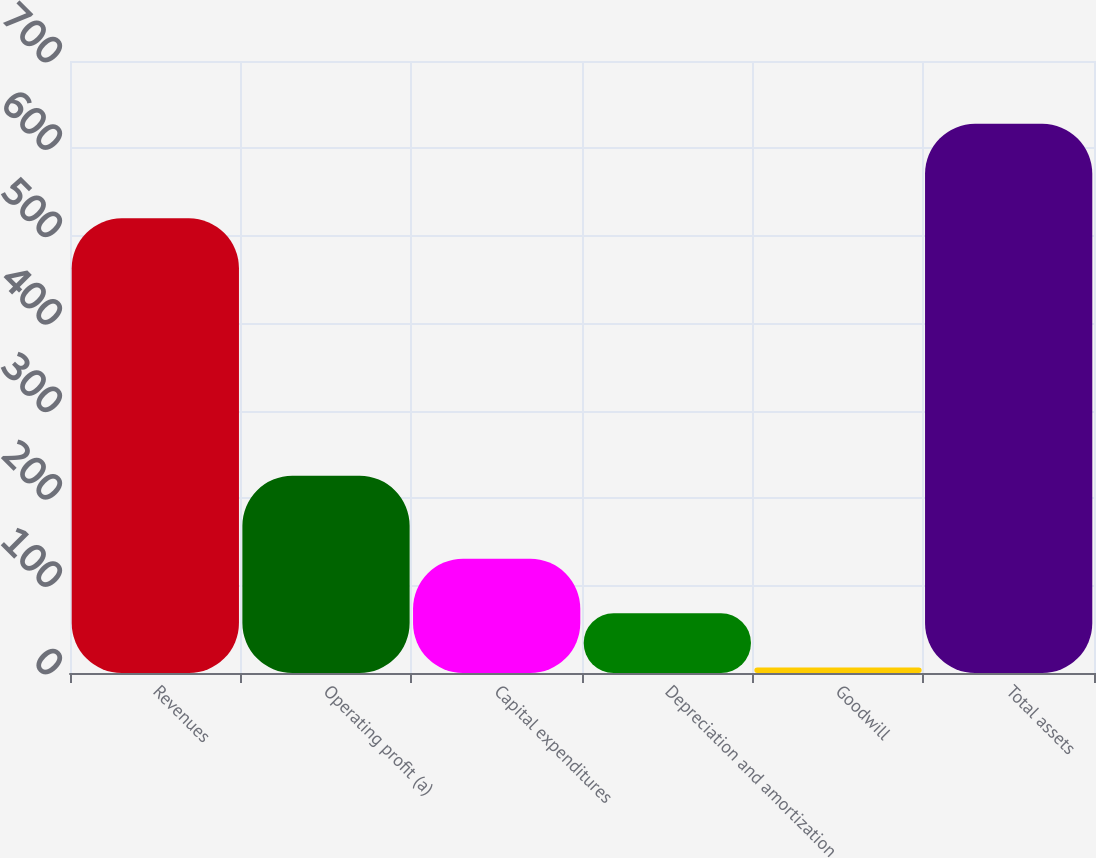Convert chart. <chart><loc_0><loc_0><loc_500><loc_500><bar_chart><fcel>Revenues<fcel>Operating profit (a)<fcel>Capital expenditures<fcel>Depreciation and amortization<fcel>Goodwill<fcel>Total assets<nl><fcel>520<fcel>225.6<fcel>130.66<fcel>68.48<fcel>6.3<fcel>628.1<nl></chart> 